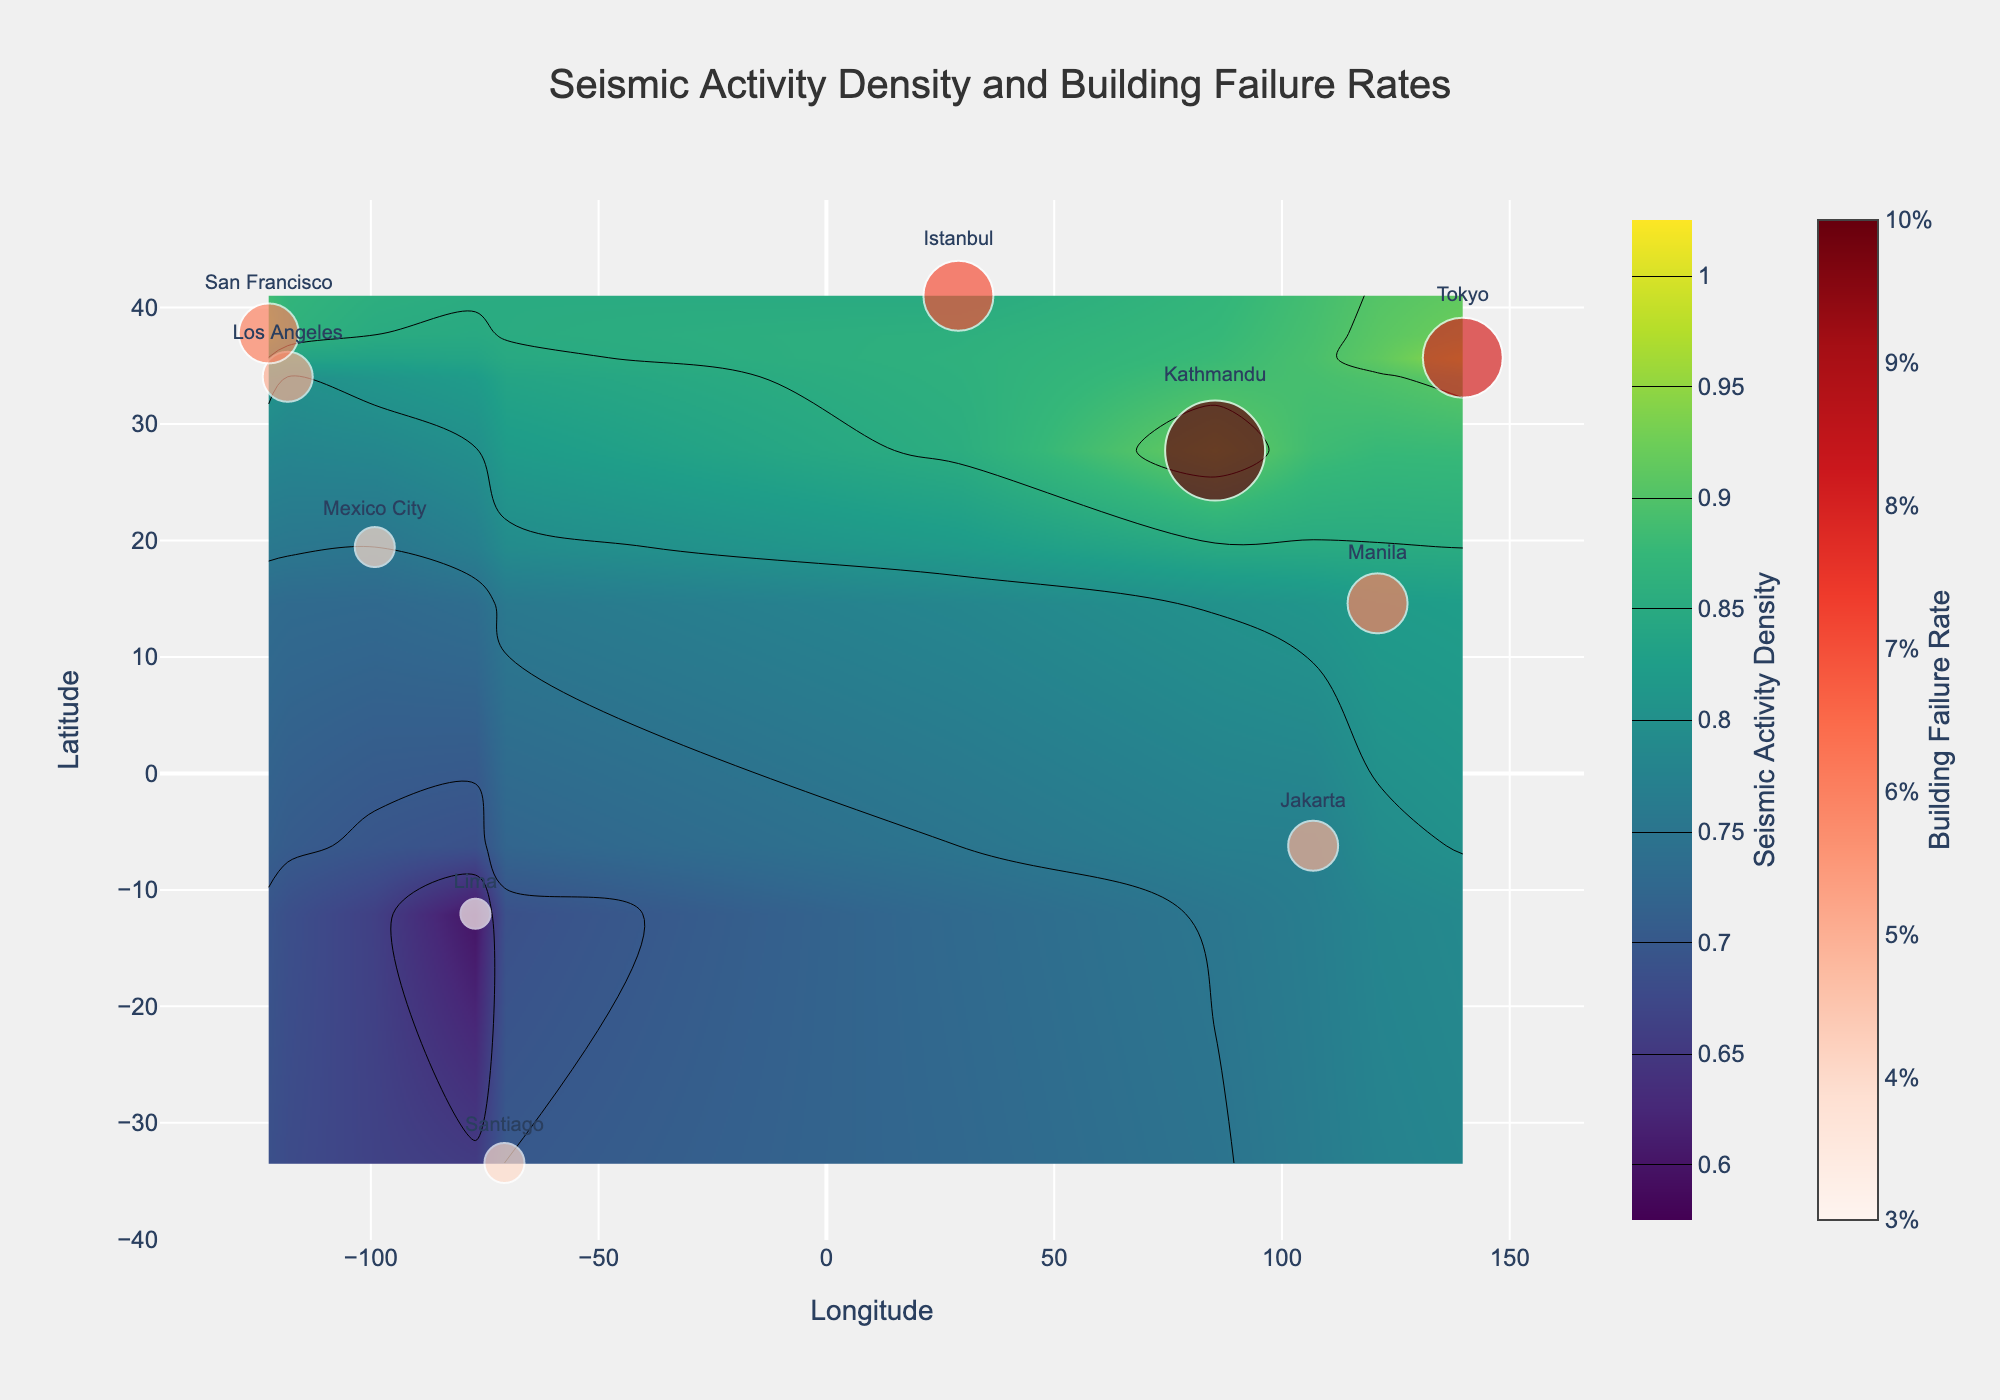What is the title of the figure? The title is the text prominently displayed at the top of the figure. It is designed to quickly convey the main topic of the plot.
Answer: Seismic Activity Density and Building Failure Rates What is the lowest value of Seismic Activity Density shown in the figure? The Seismic Activity Density is represented on a scale starting from the lowest contour value. By observing the contour color bar, the lowest value is 0.6.
Answer: 0.6 How many regions are depicted in the figure? Each dot in the scatter plot corresponds to a region with its respective labels. Counting these dots gives the total number of regions.
Answer: 10 Which region has the highest Building Failure Rate and what is its Seismic Activity Density? The sizes and colors of the markers indicate Building Failure Rates. The largest marker represents the highest rate. Reading its associated label and noting its position on the color bar for Seismic Activity Density give the answer. Kathmandu, with a failure rate depicted nearest to 0.1, corresponds to a Seismic Activity Density of approximately 0.92.
Answer: Kathmandu, 0.92 Compare the Seismic Activity Density between Los Angeles and Tokyo. Which one is higher? By locating the positions of Los Angeles and Tokyo on the contour plot and comparing the corresponding Seismic Activity Density values shown through the color gradations, Tokyo exhibits a higher density.
Answer: Tokyo What is the general trend between Seismic Activity Density and Building Failure Rate? Observing both the gradations of contour lines (Seismic Activity Density) and the sizes/colors of markers (Building Failure Rate), a consistent understanding can be formed. Generally, regions with higher Seismic Activity Density shows markers with larger sizes suggesting higher Building Failure Rates.
Answer: Higher Seismic Activity Density correlates with higher Building Failure Rate Which longitude range exhibits the highest concentration of Seismic Activity Density? Observing the contour lines along the horizontal (longitude) axis where the most densely packed or highest values are shown helps identify the range. The ranges around Tokyo and its neighboring longitudes demonstrate the highest concentration.
Answer: Around 139.69 degrees What is the average Building Failure Rate for all ten regions combined? Summing the Building Failure Rates for all regions and then dividing by the total number of regions (10) gives the average. (0.05+0.06+0.08+0.07+0.04+0.05+0.03+0.10+0.04+0.06)=0.58, so the average is 0.58/10.
Answer: 0.058 How does the Building Failure Rate of Manila compare to that of Lima? Which one is higher? By locating the positions of Manila and Lima on the scatter plot and comparing the sizes and colors of their markers, building failure rate in Manila is observed to be 0.06 while that for Lima is 0.03, making Manila's higher.
Answer: Manila Which regions are characterized by both high Seismic Activity Density and high Building Failure Rate? Regions with the highest values on both scales are indicated by the darkest contour shades and largest, reddest scatter plot markers. Kathmandu and Tokyo are observed to meet these criteria.
Answer: Kathmandu and Tokyo 